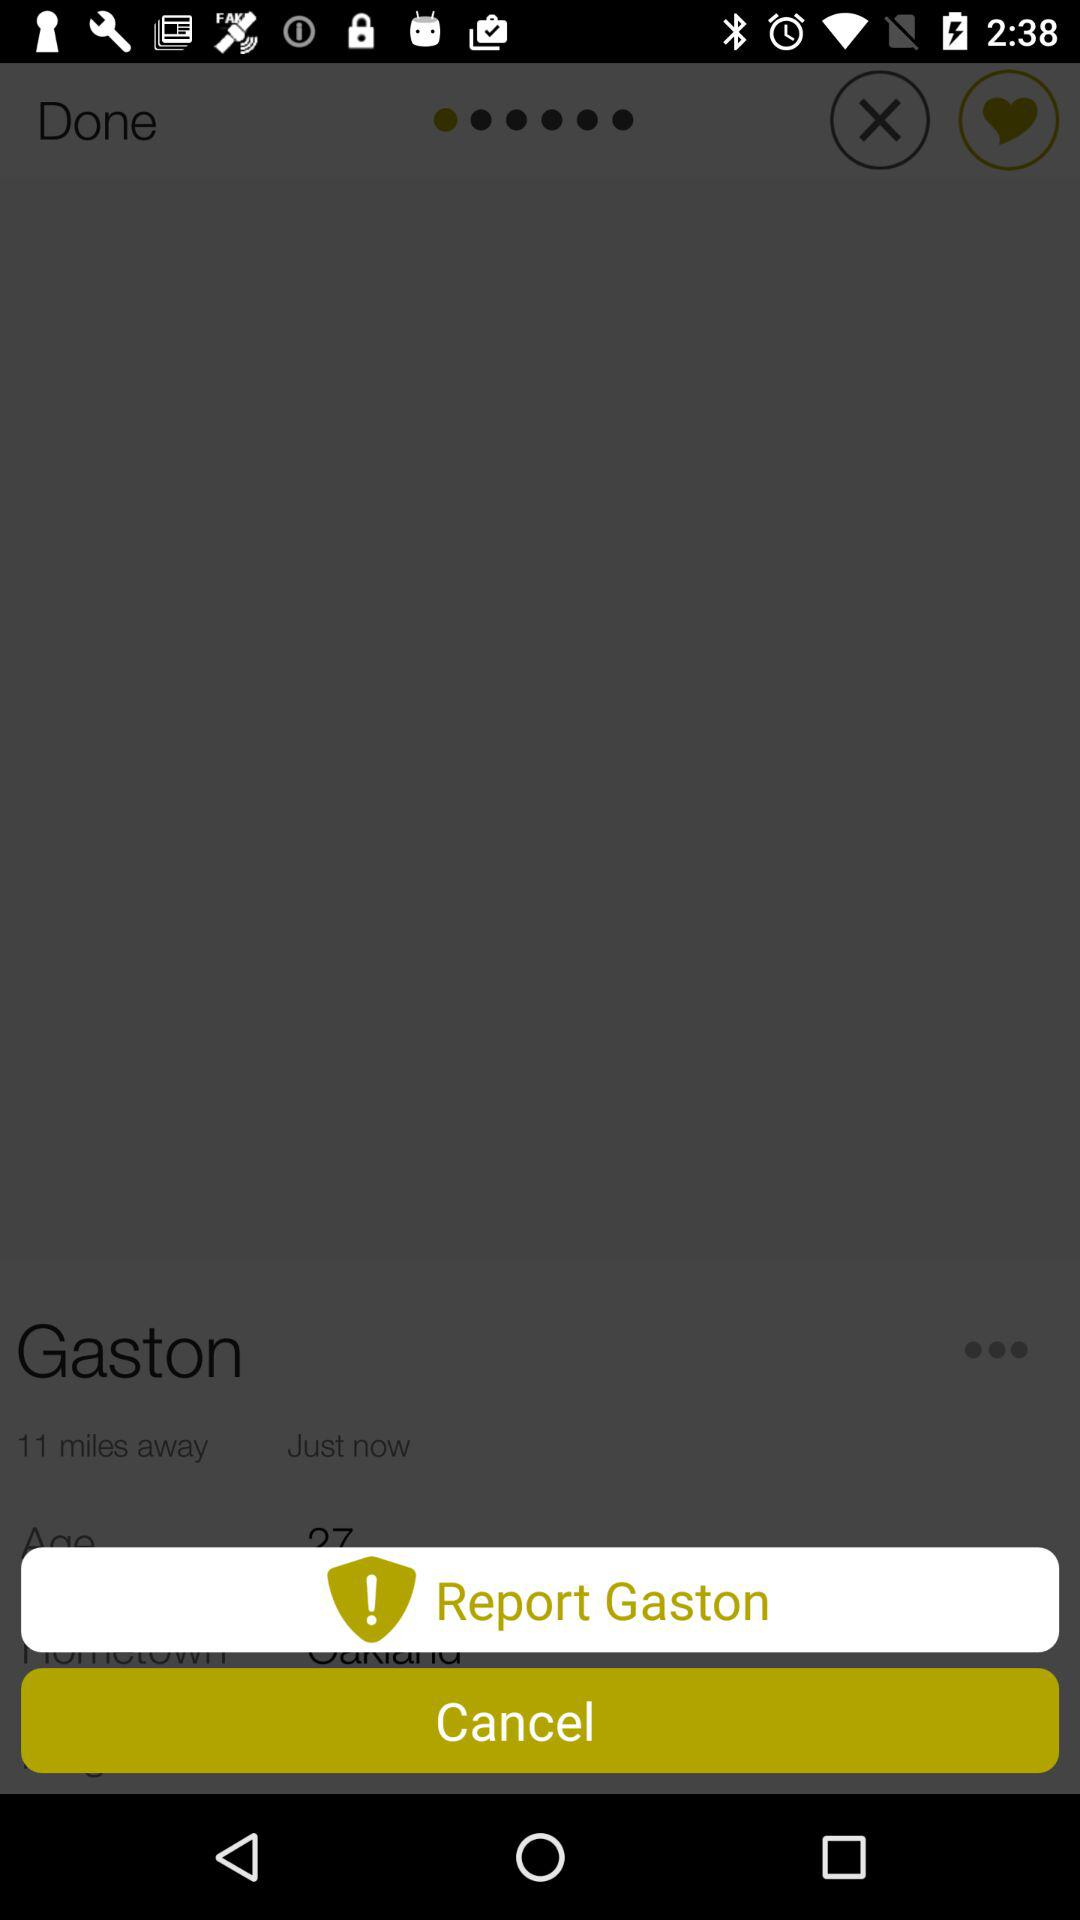How far is Gaston? Gaston is 11 miles away. 